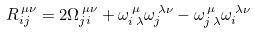<formula> <loc_0><loc_0><loc_500><loc_500>R _ { i j } ^ { \, \mu \nu } = 2 \Omega _ { j i } ^ { \, \mu \nu } + \omega ^ { \, \mu } _ { i \, \lambda } \omega _ { j } ^ { \, \lambda \nu } - \omega ^ { \, \mu } _ { j \, \lambda } \omega _ { i } ^ { \, \lambda \nu }</formula> 